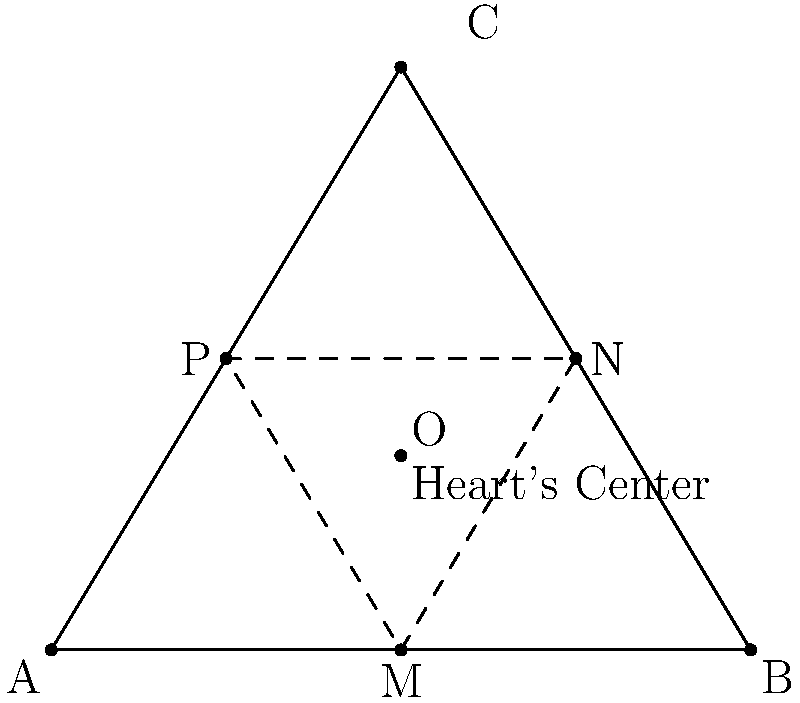In a heart-shaped region inspired by Shakespeare's love sonnets, three points form the vertices of a triangle: $A(0,0)$, $B(6,0)$, and $C(3,5)$. The midpoints of the sides of this triangle are $M$, $N$, and $P$. The center of the heart, point $O$, is located at the centroid of triangle $MNP$. Determine the coordinates of point $O$ using the midpoint formula. Let's approach this step-by-step:

1) First, find the coordinates of the midpoints $M$, $N$, and $P$:

   $M$: midpoint of $\overline{AB}$: $(\frac{0+6}{2}, \frac{0+0}{2}) = (3,0)$
   $N$: midpoint of $\overline{BC}$: $(\frac{6+3}{2}, \frac{0+5}{2}) = (4.5, 2.5)$
   $P$: midpoint of $\overline{CA}$: $(\frac{3+0}{2}, \frac{5+0}{2}) = (1.5, 2.5)$

2) The center $O$ is the centroid of triangle $MNP$. The centroid divides each median in the ratio 2:1, so we can find it by taking the average of the coordinates of $M$, $N$, and $P$:

   $O_x = \frac{M_x + N_x + P_x}{3} = \frac{3 + 4.5 + 1.5}{3} = 3$

   $O_y = \frac{M_y + N_y + P_y}{3} = \frac{0 + 2.5 + 2.5}{3} = \frac{5}{3}$

Therefore, the coordinates of the heart's center $O$ are $(3, \frac{5}{3})$.
Answer: $(3, \frac{5}{3})$ 